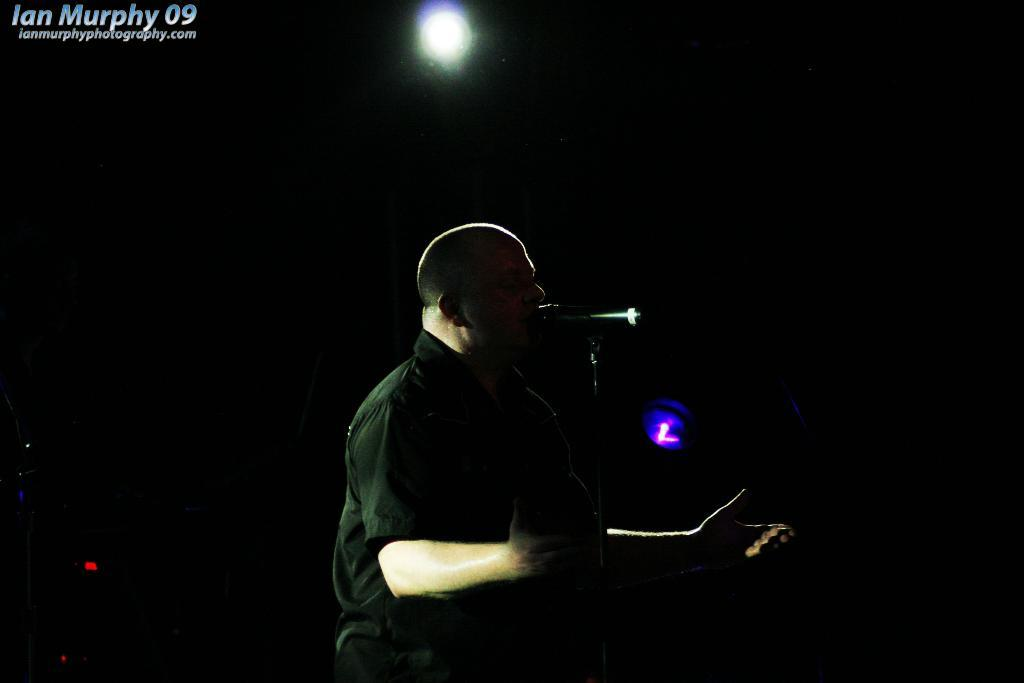What is the overall tone or mood of the image? The image is a dark photography. Can you describe the main subject of the image? There is a person in the image. What is the person doing in the image? The person is singing a song. What object is in front of the person? There is a microphone in front of the person. What type of lighting can be seen in the background of the image? There is white light in the background of the image. What type of theory is the person discussing while wearing a hat in the image? There is no indication of a theory being discussed in the image, nor is there a hat present. 